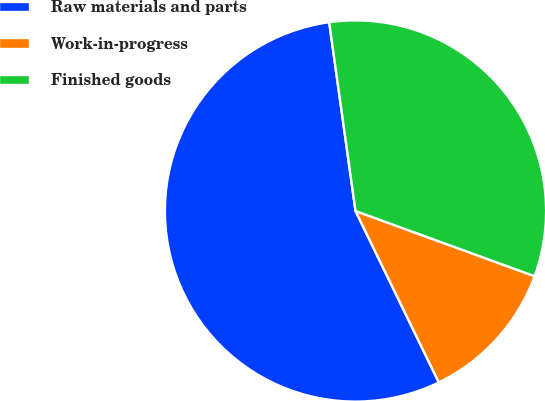Convert chart. <chart><loc_0><loc_0><loc_500><loc_500><pie_chart><fcel>Raw materials and parts<fcel>Work-in-progress<fcel>Finished goods<nl><fcel>54.99%<fcel>12.24%<fcel>32.76%<nl></chart> 